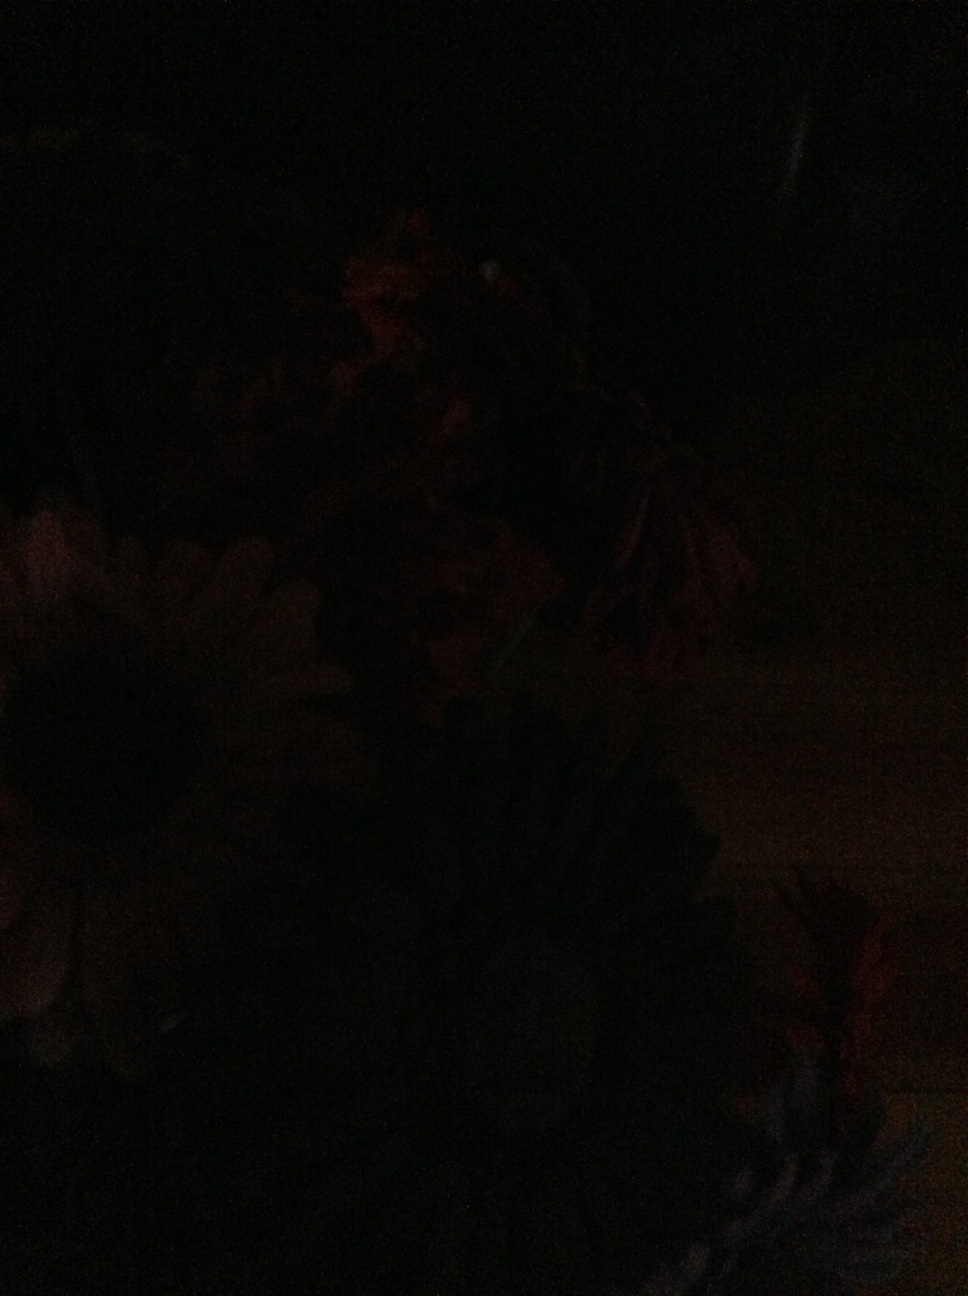What details can you observe in this image? The image appears to be quite dark, so it's challenging to make out specific details. It seems there are flowers, but their colors and other attributes are not clearly visible. Could you describe what you think might be depicted in the image based on the silhouette and any visible parts? Based on the silhouette, it looks like there are several flowers in the image. The faint outlines suggest that at least one of the flowers might be a type of daisy with petals arranged in a circular pattern, possibly among other flowers with various structures. Imagine this dark image is a scene from a magical garden. Can you create a whimsical story around it? In a mystical garden shrouded in eternal twilight, flowers with bioluminescent petals glowed softly, and the air was filled with the gentle hum of ethereal wings. Each flower bloomed differently: some radiated hues of unseen spectrums, while others whispered secrets to the night. In the center of this garden stood an ancient tree whose roots protected a hidden portal to other worlds. Every night, as the moon reached its zenith, the flowers would sing a melody that echoed through the realms, calling adventurers to discover the enchanted paradise. Imagine the flowers could talk. What might they say about their current state? If the flowers could converse, they might express a sense of tranquility and contentment in the soothing darkness, speaking in gentle tones about the peace and mysteries of the night. One might say, 'Although our colors are hidden, our beauty lies in the serenity we embody.' Another might add, 'In this darkness, we dream of dawn and the vibrant hues we will reveal at day's break.'  Is this image representative of night time or a poorly adjusted camera setting? Given the image's dark and indistinct nature, it could represent either night time, where natural light is scarce, or it might be a result of a poorly adjusted camera setting that didn't capture enough light to reveal the scene's details. 